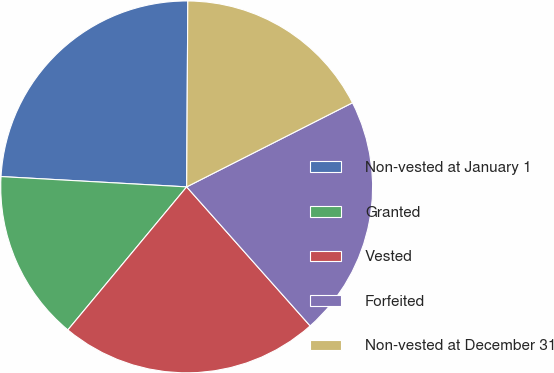<chart> <loc_0><loc_0><loc_500><loc_500><pie_chart><fcel>Non-vested at January 1<fcel>Granted<fcel>Vested<fcel>Forfeited<fcel>Non-vested at December 31<nl><fcel>24.21%<fcel>14.85%<fcel>22.59%<fcel>20.91%<fcel>17.43%<nl></chart> 